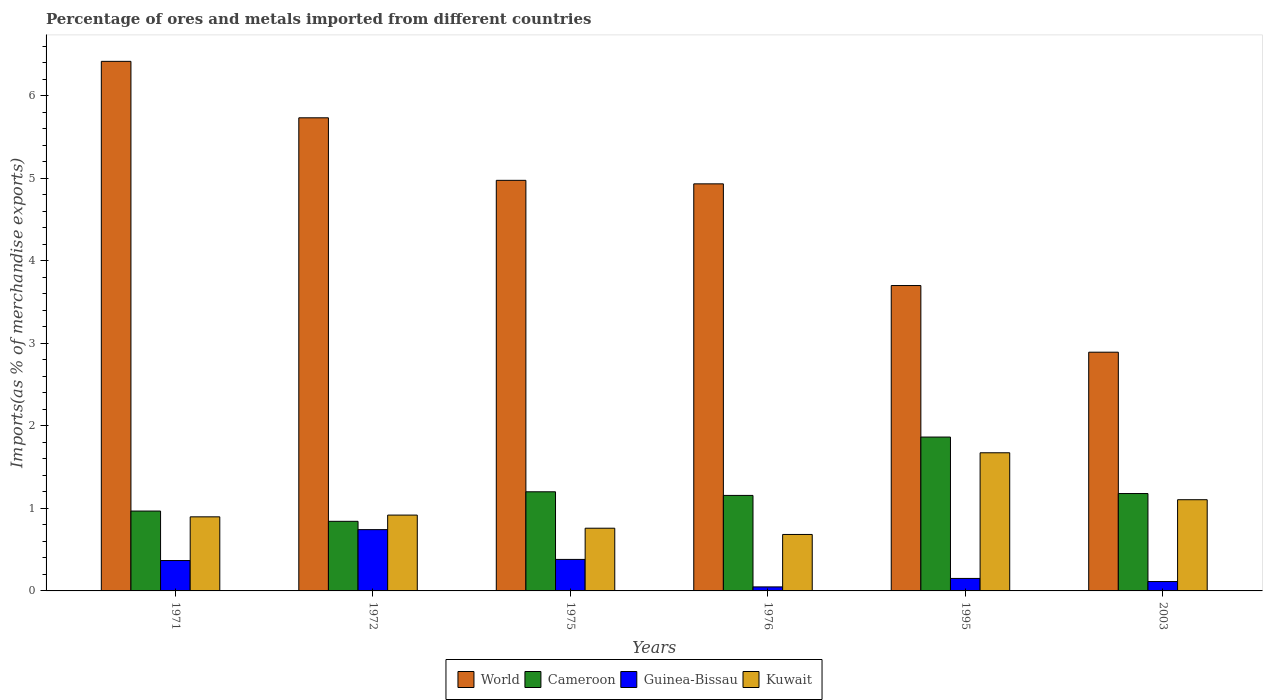Are the number of bars on each tick of the X-axis equal?
Keep it short and to the point. Yes. How many bars are there on the 4th tick from the left?
Offer a terse response. 4. How many bars are there on the 2nd tick from the right?
Your answer should be very brief. 4. In how many cases, is the number of bars for a given year not equal to the number of legend labels?
Provide a short and direct response. 0. What is the percentage of imports to different countries in Guinea-Bissau in 1972?
Ensure brevity in your answer.  0.74. Across all years, what is the maximum percentage of imports to different countries in Guinea-Bissau?
Keep it short and to the point. 0.74. Across all years, what is the minimum percentage of imports to different countries in Cameroon?
Your response must be concise. 0.84. In which year was the percentage of imports to different countries in Kuwait maximum?
Provide a succinct answer. 1995. In which year was the percentage of imports to different countries in Guinea-Bissau minimum?
Ensure brevity in your answer.  1976. What is the total percentage of imports to different countries in Guinea-Bissau in the graph?
Make the answer very short. 1.81. What is the difference between the percentage of imports to different countries in World in 1975 and that in 1995?
Your answer should be compact. 1.27. What is the difference between the percentage of imports to different countries in World in 1976 and the percentage of imports to different countries in Cameroon in 1995?
Offer a very short reply. 3.07. What is the average percentage of imports to different countries in Guinea-Bissau per year?
Keep it short and to the point. 0.3. In the year 1976, what is the difference between the percentage of imports to different countries in Guinea-Bissau and percentage of imports to different countries in World?
Make the answer very short. -4.88. In how many years, is the percentage of imports to different countries in Kuwait greater than 2 %?
Ensure brevity in your answer.  0. What is the ratio of the percentage of imports to different countries in Cameroon in 1971 to that in 2003?
Give a very brief answer. 0.82. Is the percentage of imports to different countries in Kuwait in 1971 less than that in 1976?
Give a very brief answer. No. What is the difference between the highest and the second highest percentage of imports to different countries in World?
Keep it short and to the point. 0.68. What is the difference between the highest and the lowest percentage of imports to different countries in Cameroon?
Offer a terse response. 1.02. In how many years, is the percentage of imports to different countries in Cameroon greater than the average percentage of imports to different countries in Cameroon taken over all years?
Give a very brief answer. 1. Is it the case that in every year, the sum of the percentage of imports to different countries in Kuwait and percentage of imports to different countries in Guinea-Bissau is greater than the sum of percentage of imports to different countries in Cameroon and percentage of imports to different countries in World?
Provide a succinct answer. No. What does the 3rd bar from the left in 1971 represents?
Offer a very short reply. Guinea-Bissau. What does the 3rd bar from the right in 1972 represents?
Give a very brief answer. Cameroon. How many bars are there?
Your answer should be very brief. 24. Are all the bars in the graph horizontal?
Your response must be concise. No. How many years are there in the graph?
Offer a terse response. 6. What is the difference between two consecutive major ticks on the Y-axis?
Your answer should be very brief. 1. Are the values on the major ticks of Y-axis written in scientific E-notation?
Your answer should be very brief. No. Does the graph contain any zero values?
Provide a short and direct response. No. Where does the legend appear in the graph?
Keep it short and to the point. Bottom center. What is the title of the graph?
Give a very brief answer. Percentage of ores and metals imported from different countries. Does "Lesotho" appear as one of the legend labels in the graph?
Provide a short and direct response. No. What is the label or title of the X-axis?
Make the answer very short. Years. What is the label or title of the Y-axis?
Provide a succinct answer. Imports(as % of merchandise exports). What is the Imports(as % of merchandise exports) in World in 1971?
Your answer should be compact. 6.42. What is the Imports(as % of merchandise exports) of Cameroon in 1971?
Offer a terse response. 0.97. What is the Imports(as % of merchandise exports) of Guinea-Bissau in 1971?
Make the answer very short. 0.37. What is the Imports(as % of merchandise exports) of Kuwait in 1971?
Keep it short and to the point. 0.9. What is the Imports(as % of merchandise exports) of World in 1972?
Make the answer very short. 5.73. What is the Imports(as % of merchandise exports) of Cameroon in 1972?
Make the answer very short. 0.84. What is the Imports(as % of merchandise exports) in Guinea-Bissau in 1972?
Offer a terse response. 0.74. What is the Imports(as % of merchandise exports) in Kuwait in 1972?
Your answer should be compact. 0.92. What is the Imports(as % of merchandise exports) of World in 1975?
Your answer should be compact. 4.98. What is the Imports(as % of merchandise exports) of Cameroon in 1975?
Ensure brevity in your answer.  1.2. What is the Imports(as % of merchandise exports) in Guinea-Bissau in 1975?
Keep it short and to the point. 0.38. What is the Imports(as % of merchandise exports) of Kuwait in 1975?
Offer a terse response. 0.76. What is the Imports(as % of merchandise exports) of World in 1976?
Ensure brevity in your answer.  4.93. What is the Imports(as % of merchandise exports) in Cameroon in 1976?
Make the answer very short. 1.16. What is the Imports(as % of merchandise exports) in Guinea-Bissau in 1976?
Offer a very short reply. 0.05. What is the Imports(as % of merchandise exports) of Kuwait in 1976?
Ensure brevity in your answer.  0.68. What is the Imports(as % of merchandise exports) of World in 1995?
Provide a succinct answer. 3.7. What is the Imports(as % of merchandise exports) in Cameroon in 1995?
Make the answer very short. 1.86. What is the Imports(as % of merchandise exports) of Guinea-Bissau in 1995?
Keep it short and to the point. 0.15. What is the Imports(as % of merchandise exports) of Kuwait in 1995?
Keep it short and to the point. 1.67. What is the Imports(as % of merchandise exports) in World in 2003?
Make the answer very short. 2.89. What is the Imports(as % of merchandise exports) of Cameroon in 2003?
Offer a terse response. 1.18. What is the Imports(as % of merchandise exports) in Guinea-Bissau in 2003?
Offer a very short reply. 0.11. What is the Imports(as % of merchandise exports) in Kuwait in 2003?
Offer a very short reply. 1.11. Across all years, what is the maximum Imports(as % of merchandise exports) of World?
Provide a succinct answer. 6.42. Across all years, what is the maximum Imports(as % of merchandise exports) in Cameroon?
Give a very brief answer. 1.86. Across all years, what is the maximum Imports(as % of merchandise exports) in Guinea-Bissau?
Your answer should be very brief. 0.74. Across all years, what is the maximum Imports(as % of merchandise exports) in Kuwait?
Make the answer very short. 1.67. Across all years, what is the minimum Imports(as % of merchandise exports) in World?
Provide a succinct answer. 2.89. Across all years, what is the minimum Imports(as % of merchandise exports) of Cameroon?
Give a very brief answer. 0.84. Across all years, what is the minimum Imports(as % of merchandise exports) in Guinea-Bissau?
Offer a terse response. 0.05. Across all years, what is the minimum Imports(as % of merchandise exports) in Kuwait?
Your answer should be compact. 0.68. What is the total Imports(as % of merchandise exports) in World in the graph?
Ensure brevity in your answer.  28.65. What is the total Imports(as % of merchandise exports) of Cameroon in the graph?
Keep it short and to the point. 7.21. What is the total Imports(as % of merchandise exports) in Guinea-Bissau in the graph?
Provide a succinct answer. 1.81. What is the total Imports(as % of merchandise exports) of Kuwait in the graph?
Offer a terse response. 6.04. What is the difference between the Imports(as % of merchandise exports) in World in 1971 and that in 1972?
Your answer should be compact. 0.68. What is the difference between the Imports(as % of merchandise exports) in Cameroon in 1971 and that in 1972?
Your answer should be compact. 0.12. What is the difference between the Imports(as % of merchandise exports) in Guinea-Bissau in 1971 and that in 1972?
Keep it short and to the point. -0.37. What is the difference between the Imports(as % of merchandise exports) of Kuwait in 1971 and that in 1972?
Provide a short and direct response. -0.02. What is the difference between the Imports(as % of merchandise exports) of World in 1971 and that in 1975?
Ensure brevity in your answer.  1.44. What is the difference between the Imports(as % of merchandise exports) in Cameroon in 1971 and that in 1975?
Offer a very short reply. -0.23. What is the difference between the Imports(as % of merchandise exports) of Guinea-Bissau in 1971 and that in 1975?
Your answer should be compact. -0.01. What is the difference between the Imports(as % of merchandise exports) in Kuwait in 1971 and that in 1975?
Offer a very short reply. 0.14. What is the difference between the Imports(as % of merchandise exports) of World in 1971 and that in 1976?
Make the answer very short. 1.48. What is the difference between the Imports(as % of merchandise exports) in Cameroon in 1971 and that in 1976?
Your answer should be compact. -0.19. What is the difference between the Imports(as % of merchandise exports) in Guinea-Bissau in 1971 and that in 1976?
Give a very brief answer. 0.32. What is the difference between the Imports(as % of merchandise exports) in Kuwait in 1971 and that in 1976?
Make the answer very short. 0.21. What is the difference between the Imports(as % of merchandise exports) in World in 1971 and that in 1995?
Keep it short and to the point. 2.72. What is the difference between the Imports(as % of merchandise exports) in Cameroon in 1971 and that in 1995?
Give a very brief answer. -0.9. What is the difference between the Imports(as % of merchandise exports) in Guinea-Bissau in 1971 and that in 1995?
Your answer should be very brief. 0.22. What is the difference between the Imports(as % of merchandise exports) in Kuwait in 1971 and that in 1995?
Your response must be concise. -0.78. What is the difference between the Imports(as % of merchandise exports) of World in 1971 and that in 2003?
Ensure brevity in your answer.  3.52. What is the difference between the Imports(as % of merchandise exports) of Cameroon in 1971 and that in 2003?
Keep it short and to the point. -0.21. What is the difference between the Imports(as % of merchandise exports) in Guinea-Bissau in 1971 and that in 2003?
Your response must be concise. 0.25. What is the difference between the Imports(as % of merchandise exports) in Kuwait in 1971 and that in 2003?
Your answer should be compact. -0.21. What is the difference between the Imports(as % of merchandise exports) of World in 1972 and that in 1975?
Keep it short and to the point. 0.76. What is the difference between the Imports(as % of merchandise exports) of Cameroon in 1972 and that in 1975?
Give a very brief answer. -0.36. What is the difference between the Imports(as % of merchandise exports) in Guinea-Bissau in 1972 and that in 1975?
Keep it short and to the point. 0.36. What is the difference between the Imports(as % of merchandise exports) in Kuwait in 1972 and that in 1975?
Ensure brevity in your answer.  0.16. What is the difference between the Imports(as % of merchandise exports) in World in 1972 and that in 1976?
Keep it short and to the point. 0.8. What is the difference between the Imports(as % of merchandise exports) in Cameroon in 1972 and that in 1976?
Make the answer very short. -0.31. What is the difference between the Imports(as % of merchandise exports) in Guinea-Bissau in 1972 and that in 1976?
Provide a succinct answer. 0.69. What is the difference between the Imports(as % of merchandise exports) in Kuwait in 1972 and that in 1976?
Offer a terse response. 0.23. What is the difference between the Imports(as % of merchandise exports) of World in 1972 and that in 1995?
Provide a short and direct response. 2.03. What is the difference between the Imports(as % of merchandise exports) of Cameroon in 1972 and that in 1995?
Give a very brief answer. -1.02. What is the difference between the Imports(as % of merchandise exports) of Guinea-Bissau in 1972 and that in 1995?
Your answer should be compact. 0.59. What is the difference between the Imports(as % of merchandise exports) of Kuwait in 1972 and that in 1995?
Your response must be concise. -0.76. What is the difference between the Imports(as % of merchandise exports) in World in 1972 and that in 2003?
Keep it short and to the point. 2.84. What is the difference between the Imports(as % of merchandise exports) in Cameroon in 1972 and that in 2003?
Ensure brevity in your answer.  -0.34. What is the difference between the Imports(as % of merchandise exports) of Guinea-Bissau in 1972 and that in 2003?
Your answer should be compact. 0.63. What is the difference between the Imports(as % of merchandise exports) of Kuwait in 1972 and that in 2003?
Provide a short and direct response. -0.19. What is the difference between the Imports(as % of merchandise exports) in World in 1975 and that in 1976?
Your answer should be compact. 0.04. What is the difference between the Imports(as % of merchandise exports) of Cameroon in 1975 and that in 1976?
Keep it short and to the point. 0.04. What is the difference between the Imports(as % of merchandise exports) in Guinea-Bissau in 1975 and that in 1976?
Ensure brevity in your answer.  0.33. What is the difference between the Imports(as % of merchandise exports) in Kuwait in 1975 and that in 1976?
Offer a terse response. 0.08. What is the difference between the Imports(as % of merchandise exports) of World in 1975 and that in 1995?
Provide a succinct answer. 1.27. What is the difference between the Imports(as % of merchandise exports) in Cameroon in 1975 and that in 1995?
Provide a succinct answer. -0.66. What is the difference between the Imports(as % of merchandise exports) of Guinea-Bissau in 1975 and that in 1995?
Offer a terse response. 0.23. What is the difference between the Imports(as % of merchandise exports) of Kuwait in 1975 and that in 1995?
Provide a succinct answer. -0.91. What is the difference between the Imports(as % of merchandise exports) in World in 1975 and that in 2003?
Provide a succinct answer. 2.08. What is the difference between the Imports(as % of merchandise exports) in Cameroon in 1975 and that in 2003?
Ensure brevity in your answer.  0.02. What is the difference between the Imports(as % of merchandise exports) of Guinea-Bissau in 1975 and that in 2003?
Your answer should be compact. 0.27. What is the difference between the Imports(as % of merchandise exports) in Kuwait in 1975 and that in 2003?
Ensure brevity in your answer.  -0.35. What is the difference between the Imports(as % of merchandise exports) in World in 1976 and that in 1995?
Your response must be concise. 1.23. What is the difference between the Imports(as % of merchandise exports) of Cameroon in 1976 and that in 1995?
Offer a terse response. -0.71. What is the difference between the Imports(as % of merchandise exports) of Guinea-Bissau in 1976 and that in 1995?
Provide a short and direct response. -0.1. What is the difference between the Imports(as % of merchandise exports) in Kuwait in 1976 and that in 1995?
Give a very brief answer. -0.99. What is the difference between the Imports(as % of merchandise exports) in World in 1976 and that in 2003?
Provide a succinct answer. 2.04. What is the difference between the Imports(as % of merchandise exports) in Cameroon in 1976 and that in 2003?
Offer a very short reply. -0.02. What is the difference between the Imports(as % of merchandise exports) in Guinea-Bissau in 1976 and that in 2003?
Give a very brief answer. -0.07. What is the difference between the Imports(as % of merchandise exports) of Kuwait in 1976 and that in 2003?
Keep it short and to the point. -0.42. What is the difference between the Imports(as % of merchandise exports) in World in 1995 and that in 2003?
Provide a succinct answer. 0.81. What is the difference between the Imports(as % of merchandise exports) of Cameroon in 1995 and that in 2003?
Your answer should be compact. 0.68. What is the difference between the Imports(as % of merchandise exports) in Guinea-Bissau in 1995 and that in 2003?
Provide a short and direct response. 0.04. What is the difference between the Imports(as % of merchandise exports) in Kuwait in 1995 and that in 2003?
Your answer should be compact. 0.57. What is the difference between the Imports(as % of merchandise exports) of World in 1971 and the Imports(as % of merchandise exports) of Cameroon in 1972?
Your answer should be compact. 5.57. What is the difference between the Imports(as % of merchandise exports) in World in 1971 and the Imports(as % of merchandise exports) in Guinea-Bissau in 1972?
Make the answer very short. 5.67. What is the difference between the Imports(as % of merchandise exports) in World in 1971 and the Imports(as % of merchandise exports) in Kuwait in 1972?
Provide a short and direct response. 5.5. What is the difference between the Imports(as % of merchandise exports) of Cameroon in 1971 and the Imports(as % of merchandise exports) of Guinea-Bissau in 1972?
Your response must be concise. 0.23. What is the difference between the Imports(as % of merchandise exports) of Cameroon in 1971 and the Imports(as % of merchandise exports) of Kuwait in 1972?
Make the answer very short. 0.05. What is the difference between the Imports(as % of merchandise exports) in Guinea-Bissau in 1971 and the Imports(as % of merchandise exports) in Kuwait in 1972?
Offer a terse response. -0.55. What is the difference between the Imports(as % of merchandise exports) in World in 1971 and the Imports(as % of merchandise exports) in Cameroon in 1975?
Offer a very short reply. 5.22. What is the difference between the Imports(as % of merchandise exports) of World in 1971 and the Imports(as % of merchandise exports) of Guinea-Bissau in 1975?
Provide a short and direct response. 6.04. What is the difference between the Imports(as % of merchandise exports) of World in 1971 and the Imports(as % of merchandise exports) of Kuwait in 1975?
Ensure brevity in your answer.  5.66. What is the difference between the Imports(as % of merchandise exports) of Cameroon in 1971 and the Imports(as % of merchandise exports) of Guinea-Bissau in 1975?
Offer a terse response. 0.59. What is the difference between the Imports(as % of merchandise exports) of Cameroon in 1971 and the Imports(as % of merchandise exports) of Kuwait in 1975?
Offer a terse response. 0.21. What is the difference between the Imports(as % of merchandise exports) in Guinea-Bissau in 1971 and the Imports(as % of merchandise exports) in Kuwait in 1975?
Provide a short and direct response. -0.39. What is the difference between the Imports(as % of merchandise exports) in World in 1971 and the Imports(as % of merchandise exports) in Cameroon in 1976?
Give a very brief answer. 5.26. What is the difference between the Imports(as % of merchandise exports) of World in 1971 and the Imports(as % of merchandise exports) of Guinea-Bissau in 1976?
Offer a terse response. 6.37. What is the difference between the Imports(as % of merchandise exports) of World in 1971 and the Imports(as % of merchandise exports) of Kuwait in 1976?
Give a very brief answer. 5.73. What is the difference between the Imports(as % of merchandise exports) in Cameroon in 1971 and the Imports(as % of merchandise exports) in Guinea-Bissau in 1976?
Offer a terse response. 0.92. What is the difference between the Imports(as % of merchandise exports) in Cameroon in 1971 and the Imports(as % of merchandise exports) in Kuwait in 1976?
Make the answer very short. 0.28. What is the difference between the Imports(as % of merchandise exports) of Guinea-Bissau in 1971 and the Imports(as % of merchandise exports) of Kuwait in 1976?
Your response must be concise. -0.32. What is the difference between the Imports(as % of merchandise exports) of World in 1971 and the Imports(as % of merchandise exports) of Cameroon in 1995?
Provide a short and direct response. 4.55. What is the difference between the Imports(as % of merchandise exports) of World in 1971 and the Imports(as % of merchandise exports) of Guinea-Bissau in 1995?
Your answer should be very brief. 6.27. What is the difference between the Imports(as % of merchandise exports) in World in 1971 and the Imports(as % of merchandise exports) in Kuwait in 1995?
Keep it short and to the point. 4.74. What is the difference between the Imports(as % of merchandise exports) in Cameroon in 1971 and the Imports(as % of merchandise exports) in Guinea-Bissau in 1995?
Give a very brief answer. 0.82. What is the difference between the Imports(as % of merchandise exports) in Cameroon in 1971 and the Imports(as % of merchandise exports) in Kuwait in 1995?
Ensure brevity in your answer.  -0.71. What is the difference between the Imports(as % of merchandise exports) of Guinea-Bissau in 1971 and the Imports(as % of merchandise exports) of Kuwait in 1995?
Offer a very short reply. -1.31. What is the difference between the Imports(as % of merchandise exports) in World in 1971 and the Imports(as % of merchandise exports) in Cameroon in 2003?
Your answer should be very brief. 5.24. What is the difference between the Imports(as % of merchandise exports) of World in 1971 and the Imports(as % of merchandise exports) of Guinea-Bissau in 2003?
Give a very brief answer. 6.3. What is the difference between the Imports(as % of merchandise exports) in World in 1971 and the Imports(as % of merchandise exports) in Kuwait in 2003?
Make the answer very short. 5.31. What is the difference between the Imports(as % of merchandise exports) in Cameroon in 1971 and the Imports(as % of merchandise exports) in Guinea-Bissau in 2003?
Your answer should be very brief. 0.85. What is the difference between the Imports(as % of merchandise exports) in Cameroon in 1971 and the Imports(as % of merchandise exports) in Kuwait in 2003?
Offer a terse response. -0.14. What is the difference between the Imports(as % of merchandise exports) of Guinea-Bissau in 1971 and the Imports(as % of merchandise exports) of Kuwait in 2003?
Ensure brevity in your answer.  -0.74. What is the difference between the Imports(as % of merchandise exports) of World in 1972 and the Imports(as % of merchandise exports) of Cameroon in 1975?
Provide a succinct answer. 4.53. What is the difference between the Imports(as % of merchandise exports) in World in 1972 and the Imports(as % of merchandise exports) in Guinea-Bissau in 1975?
Your answer should be very brief. 5.35. What is the difference between the Imports(as % of merchandise exports) in World in 1972 and the Imports(as % of merchandise exports) in Kuwait in 1975?
Your response must be concise. 4.97. What is the difference between the Imports(as % of merchandise exports) in Cameroon in 1972 and the Imports(as % of merchandise exports) in Guinea-Bissau in 1975?
Provide a short and direct response. 0.46. What is the difference between the Imports(as % of merchandise exports) of Cameroon in 1972 and the Imports(as % of merchandise exports) of Kuwait in 1975?
Provide a succinct answer. 0.08. What is the difference between the Imports(as % of merchandise exports) of Guinea-Bissau in 1972 and the Imports(as % of merchandise exports) of Kuwait in 1975?
Your answer should be compact. -0.02. What is the difference between the Imports(as % of merchandise exports) in World in 1972 and the Imports(as % of merchandise exports) in Cameroon in 1976?
Ensure brevity in your answer.  4.58. What is the difference between the Imports(as % of merchandise exports) in World in 1972 and the Imports(as % of merchandise exports) in Guinea-Bissau in 1976?
Your response must be concise. 5.68. What is the difference between the Imports(as % of merchandise exports) in World in 1972 and the Imports(as % of merchandise exports) in Kuwait in 1976?
Provide a succinct answer. 5.05. What is the difference between the Imports(as % of merchandise exports) in Cameroon in 1972 and the Imports(as % of merchandise exports) in Guinea-Bissau in 1976?
Offer a very short reply. 0.79. What is the difference between the Imports(as % of merchandise exports) of Cameroon in 1972 and the Imports(as % of merchandise exports) of Kuwait in 1976?
Give a very brief answer. 0.16. What is the difference between the Imports(as % of merchandise exports) of Guinea-Bissau in 1972 and the Imports(as % of merchandise exports) of Kuwait in 1976?
Your response must be concise. 0.06. What is the difference between the Imports(as % of merchandise exports) of World in 1972 and the Imports(as % of merchandise exports) of Cameroon in 1995?
Your response must be concise. 3.87. What is the difference between the Imports(as % of merchandise exports) of World in 1972 and the Imports(as % of merchandise exports) of Guinea-Bissau in 1995?
Give a very brief answer. 5.58. What is the difference between the Imports(as % of merchandise exports) of World in 1972 and the Imports(as % of merchandise exports) of Kuwait in 1995?
Your response must be concise. 4.06. What is the difference between the Imports(as % of merchandise exports) of Cameroon in 1972 and the Imports(as % of merchandise exports) of Guinea-Bissau in 1995?
Ensure brevity in your answer.  0.69. What is the difference between the Imports(as % of merchandise exports) of Cameroon in 1972 and the Imports(as % of merchandise exports) of Kuwait in 1995?
Make the answer very short. -0.83. What is the difference between the Imports(as % of merchandise exports) in Guinea-Bissau in 1972 and the Imports(as % of merchandise exports) in Kuwait in 1995?
Offer a terse response. -0.93. What is the difference between the Imports(as % of merchandise exports) of World in 1972 and the Imports(as % of merchandise exports) of Cameroon in 2003?
Your answer should be compact. 4.55. What is the difference between the Imports(as % of merchandise exports) of World in 1972 and the Imports(as % of merchandise exports) of Guinea-Bissau in 2003?
Give a very brief answer. 5.62. What is the difference between the Imports(as % of merchandise exports) of World in 1972 and the Imports(as % of merchandise exports) of Kuwait in 2003?
Provide a short and direct response. 4.63. What is the difference between the Imports(as % of merchandise exports) of Cameroon in 1972 and the Imports(as % of merchandise exports) of Guinea-Bissau in 2003?
Give a very brief answer. 0.73. What is the difference between the Imports(as % of merchandise exports) in Cameroon in 1972 and the Imports(as % of merchandise exports) in Kuwait in 2003?
Make the answer very short. -0.26. What is the difference between the Imports(as % of merchandise exports) in Guinea-Bissau in 1972 and the Imports(as % of merchandise exports) in Kuwait in 2003?
Keep it short and to the point. -0.36. What is the difference between the Imports(as % of merchandise exports) of World in 1975 and the Imports(as % of merchandise exports) of Cameroon in 1976?
Your response must be concise. 3.82. What is the difference between the Imports(as % of merchandise exports) in World in 1975 and the Imports(as % of merchandise exports) in Guinea-Bissau in 1976?
Provide a short and direct response. 4.93. What is the difference between the Imports(as % of merchandise exports) in World in 1975 and the Imports(as % of merchandise exports) in Kuwait in 1976?
Make the answer very short. 4.29. What is the difference between the Imports(as % of merchandise exports) in Cameroon in 1975 and the Imports(as % of merchandise exports) in Guinea-Bissau in 1976?
Your response must be concise. 1.15. What is the difference between the Imports(as % of merchandise exports) in Cameroon in 1975 and the Imports(as % of merchandise exports) in Kuwait in 1976?
Make the answer very short. 0.52. What is the difference between the Imports(as % of merchandise exports) in Guinea-Bissau in 1975 and the Imports(as % of merchandise exports) in Kuwait in 1976?
Offer a very short reply. -0.3. What is the difference between the Imports(as % of merchandise exports) of World in 1975 and the Imports(as % of merchandise exports) of Cameroon in 1995?
Your answer should be very brief. 3.11. What is the difference between the Imports(as % of merchandise exports) in World in 1975 and the Imports(as % of merchandise exports) in Guinea-Bissau in 1995?
Offer a very short reply. 4.82. What is the difference between the Imports(as % of merchandise exports) of World in 1975 and the Imports(as % of merchandise exports) of Kuwait in 1995?
Provide a succinct answer. 3.3. What is the difference between the Imports(as % of merchandise exports) in Cameroon in 1975 and the Imports(as % of merchandise exports) in Guinea-Bissau in 1995?
Your response must be concise. 1.05. What is the difference between the Imports(as % of merchandise exports) in Cameroon in 1975 and the Imports(as % of merchandise exports) in Kuwait in 1995?
Your answer should be compact. -0.47. What is the difference between the Imports(as % of merchandise exports) in Guinea-Bissau in 1975 and the Imports(as % of merchandise exports) in Kuwait in 1995?
Ensure brevity in your answer.  -1.29. What is the difference between the Imports(as % of merchandise exports) of World in 1975 and the Imports(as % of merchandise exports) of Cameroon in 2003?
Make the answer very short. 3.8. What is the difference between the Imports(as % of merchandise exports) in World in 1975 and the Imports(as % of merchandise exports) in Guinea-Bissau in 2003?
Provide a succinct answer. 4.86. What is the difference between the Imports(as % of merchandise exports) of World in 1975 and the Imports(as % of merchandise exports) of Kuwait in 2003?
Keep it short and to the point. 3.87. What is the difference between the Imports(as % of merchandise exports) of Cameroon in 1975 and the Imports(as % of merchandise exports) of Guinea-Bissau in 2003?
Ensure brevity in your answer.  1.09. What is the difference between the Imports(as % of merchandise exports) of Cameroon in 1975 and the Imports(as % of merchandise exports) of Kuwait in 2003?
Your answer should be very brief. 0.1. What is the difference between the Imports(as % of merchandise exports) in Guinea-Bissau in 1975 and the Imports(as % of merchandise exports) in Kuwait in 2003?
Offer a very short reply. -0.72. What is the difference between the Imports(as % of merchandise exports) of World in 1976 and the Imports(as % of merchandise exports) of Cameroon in 1995?
Make the answer very short. 3.07. What is the difference between the Imports(as % of merchandise exports) in World in 1976 and the Imports(as % of merchandise exports) in Guinea-Bissau in 1995?
Provide a short and direct response. 4.78. What is the difference between the Imports(as % of merchandise exports) of World in 1976 and the Imports(as % of merchandise exports) of Kuwait in 1995?
Offer a terse response. 3.26. What is the difference between the Imports(as % of merchandise exports) of Cameroon in 1976 and the Imports(as % of merchandise exports) of Guinea-Bissau in 1995?
Give a very brief answer. 1.01. What is the difference between the Imports(as % of merchandise exports) of Cameroon in 1976 and the Imports(as % of merchandise exports) of Kuwait in 1995?
Offer a very short reply. -0.52. What is the difference between the Imports(as % of merchandise exports) of Guinea-Bissau in 1976 and the Imports(as % of merchandise exports) of Kuwait in 1995?
Keep it short and to the point. -1.63. What is the difference between the Imports(as % of merchandise exports) of World in 1976 and the Imports(as % of merchandise exports) of Cameroon in 2003?
Provide a short and direct response. 3.75. What is the difference between the Imports(as % of merchandise exports) of World in 1976 and the Imports(as % of merchandise exports) of Guinea-Bissau in 2003?
Your answer should be compact. 4.82. What is the difference between the Imports(as % of merchandise exports) of World in 1976 and the Imports(as % of merchandise exports) of Kuwait in 2003?
Your answer should be very brief. 3.83. What is the difference between the Imports(as % of merchandise exports) in Cameroon in 1976 and the Imports(as % of merchandise exports) in Guinea-Bissau in 2003?
Make the answer very short. 1.04. What is the difference between the Imports(as % of merchandise exports) in Cameroon in 1976 and the Imports(as % of merchandise exports) in Kuwait in 2003?
Provide a short and direct response. 0.05. What is the difference between the Imports(as % of merchandise exports) of Guinea-Bissau in 1976 and the Imports(as % of merchandise exports) of Kuwait in 2003?
Your answer should be compact. -1.06. What is the difference between the Imports(as % of merchandise exports) in World in 1995 and the Imports(as % of merchandise exports) in Cameroon in 2003?
Ensure brevity in your answer.  2.52. What is the difference between the Imports(as % of merchandise exports) of World in 1995 and the Imports(as % of merchandise exports) of Guinea-Bissau in 2003?
Your answer should be compact. 3.59. What is the difference between the Imports(as % of merchandise exports) of World in 1995 and the Imports(as % of merchandise exports) of Kuwait in 2003?
Give a very brief answer. 2.6. What is the difference between the Imports(as % of merchandise exports) of Cameroon in 1995 and the Imports(as % of merchandise exports) of Guinea-Bissau in 2003?
Keep it short and to the point. 1.75. What is the difference between the Imports(as % of merchandise exports) in Cameroon in 1995 and the Imports(as % of merchandise exports) in Kuwait in 2003?
Offer a very short reply. 0.76. What is the difference between the Imports(as % of merchandise exports) in Guinea-Bissau in 1995 and the Imports(as % of merchandise exports) in Kuwait in 2003?
Keep it short and to the point. -0.95. What is the average Imports(as % of merchandise exports) in World per year?
Provide a succinct answer. 4.78. What is the average Imports(as % of merchandise exports) of Cameroon per year?
Ensure brevity in your answer.  1.2. What is the average Imports(as % of merchandise exports) of Guinea-Bissau per year?
Provide a succinct answer. 0.3. What is the average Imports(as % of merchandise exports) in Kuwait per year?
Make the answer very short. 1.01. In the year 1971, what is the difference between the Imports(as % of merchandise exports) in World and Imports(as % of merchandise exports) in Cameroon?
Keep it short and to the point. 5.45. In the year 1971, what is the difference between the Imports(as % of merchandise exports) of World and Imports(as % of merchandise exports) of Guinea-Bissau?
Ensure brevity in your answer.  6.05. In the year 1971, what is the difference between the Imports(as % of merchandise exports) in World and Imports(as % of merchandise exports) in Kuwait?
Ensure brevity in your answer.  5.52. In the year 1971, what is the difference between the Imports(as % of merchandise exports) of Cameroon and Imports(as % of merchandise exports) of Guinea-Bissau?
Offer a very short reply. 0.6. In the year 1971, what is the difference between the Imports(as % of merchandise exports) of Cameroon and Imports(as % of merchandise exports) of Kuwait?
Keep it short and to the point. 0.07. In the year 1971, what is the difference between the Imports(as % of merchandise exports) in Guinea-Bissau and Imports(as % of merchandise exports) in Kuwait?
Your response must be concise. -0.53. In the year 1972, what is the difference between the Imports(as % of merchandise exports) in World and Imports(as % of merchandise exports) in Cameroon?
Ensure brevity in your answer.  4.89. In the year 1972, what is the difference between the Imports(as % of merchandise exports) of World and Imports(as % of merchandise exports) of Guinea-Bissau?
Give a very brief answer. 4.99. In the year 1972, what is the difference between the Imports(as % of merchandise exports) of World and Imports(as % of merchandise exports) of Kuwait?
Make the answer very short. 4.81. In the year 1972, what is the difference between the Imports(as % of merchandise exports) in Cameroon and Imports(as % of merchandise exports) in Guinea-Bissau?
Ensure brevity in your answer.  0.1. In the year 1972, what is the difference between the Imports(as % of merchandise exports) in Cameroon and Imports(as % of merchandise exports) in Kuwait?
Your response must be concise. -0.08. In the year 1972, what is the difference between the Imports(as % of merchandise exports) in Guinea-Bissau and Imports(as % of merchandise exports) in Kuwait?
Your response must be concise. -0.18. In the year 1975, what is the difference between the Imports(as % of merchandise exports) of World and Imports(as % of merchandise exports) of Cameroon?
Ensure brevity in your answer.  3.77. In the year 1975, what is the difference between the Imports(as % of merchandise exports) in World and Imports(as % of merchandise exports) in Guinea-Bissau?
Provide a short and direct response. 4.59. In the year 1975, what is the difference between the Imports(as % of merchandise exports) of World and Imports(as % of merchandise exports) of Kuwait?
Offer a terse response. 4.22. In the year 1975, what is the difference between the Imports(as % of merchandise exports) of Cameroon and Imports(as % of merchandise exports) of Guinea-Bissau?
Offer a terse response. 0.82. In the year 1975, what is the difference between the Imports(as % of merchandise exports) of Cameroon and Imports(as % of merchandise exports) of Kuwait?
Give a very brief answer. 0.44. In the year 1975, what is the difference between the Imports(as % of merchandise exports) in Guinea-Bissau and Imports(as % of merchandise exports) in Kuwait?
Offer a terse response. -0.38. In the year 1976, what is the difference between the Imports(as % of merchandise exports) in World and Imports(as % of merchandise exports) in Cameroon?
Your response must be concise. 3.78. In the year 1976, what is the difference between the Imports(as % of merchandise exports) in World and Imports(as % of merchandise exports) in Guinea-Bissau?
Your answer should be very brief. 4.88. In the year 1976, what is the difference between the Imports(as % of merchandise exports) in World and Imports(as % of merchandise exports) in Kuwait?
Your response must be concise. 4.25. In the year 1976, what is the difference between the Imports(as % of merchandise exports) of Cameroon and Imports(as % of merchandise exports) of Guinea-Bissau?
Keep it short and to the point. 1.11. In the year 1976, what is the difference between the Imports(as % of merchandise exports) of Cameroon and Imports(as % of merchandise exports) of Kuwait?
Your response must be concise. 0.47. In the year 1976, what is the difference between the Imports(as % of merchandise exports) of Guinea-Bissau and Imports(as % of merchandise exports) of Kuwait?
Provide a short and direct response. -0.64. In the year 1995, what is the difference between the Imports(as % of merchandise exports) of World and Imports(as % of merchandise exports) of Cameroon?
Make the answer very short. 1.84. In the year 1995, what is the difference between the Imports(as % of merchandise exports) in World and Imports(as % of merchandise exports) in Guinea-Bissau?
Provide a short and direct response. 3.55. In the year 1995, what is the difference between the Imports(as % of merchandise exports) of World and Imports(as % of merchandise exports) of Kuwait?
Keep it short and to the point. 2.03. In the year 1995, what is the difference between the Imports(as % of merchandise exports) in Cameroon and Imports(as % of merchandise exports) in Guinea-Bissau?
Offer a terse response. 1.71. In the year 1995, what is the difference between the Imports(as % of merchandise exports) of Cameroon and Imports(as % of merchandise exports) of Kuwait?
Make the answer very short. 0.19. In the year 1995, what is the difference between the Imports(as % of merchandise exports) of Guinea-Bissau and Imports(as % of merchandise exports) of Kuwait?
Your response must be concise. -1.52. In the year 2003, what is the difference between the Imports(as % of merchandise exports) of World and Imports(as % of merchandise exports) of Cameroon?
Give a very brief answer. 1.71. In the year 2003, what is the difference between the Imports(as % of merchandise exports) in World and Imports(as % of merchandise exports) in Guinea-Bissau?
Your response must be concise. 2.78. In the year 2003, what is the difference between the Imports(as % of merchandise exports) of World and Imports(as % of merchandise exports) of Kuwait?
Ensure brevity in your answer.  1.79. In the year 2003, what is the difference between the Imports(as % of merchandise exports) of Cameroon and Imports(as % of merchandise exports) of Guinea-Bissau?
Provide a succinct answer. 1.07. In the year 2003, what is the difference between the Imports(as % of merchandise exports) of Cameroon and Imports(as % of merchandise exports) of Kuwait?
Provide a short and direct response. 0.07. In the year 2003, what is the difference between the Imports(as % of merchandise exports) in Guinea-Bissau and Imports(as % of merchandise exports) in Kuwait?
Keep it short and to the point. -0.99. What is the ratio of the Imports(as % of merchandise exports) in World in 1971 to that in 1972?
Provide a succinct answer. 1.12. What is the ratio of the Imports(as % of merchandise exports) of Cameroon in 1971 to that in 1972?
Offer a very short reply. 1.15. What is the ratio of the Imports(as % of merchandise exports) in Guinea-Bissau in 1971 to that in 1972?
Make the answer very short. 0.5. What is the ratio of the Imports(as % of merchandise exports) in Kuwait in 1971 to that in 1972?
Make the answer very short. 0.98. What is the ratio of the Imports(as % of merchandise exports) in World in 1971 to that in 1975?
Your response must be concise. 1.29. What is the ratio of the Imports(as % of merchandise exports) in Cameroon in 1971 to that in 1975?
Your answer should be compact. 0.81. What is the ratio of the Imports(as % of merchandise exports) in Guinea-Bissau in 1971 to that in 1975?
Your answer should be very brief. 0.96. What is the ratio of the Imports(as % of merchandise exports) of Kuwait in 1971 to that in 1975?
Your response must be concise. 1.18. What is the ratio of the Imports(as % of merchandise exports) in World in 1971 to that in 1976?
Offer a terse response. 1.3. What is the ratio of the Imports(as % of merchandise exports) of Cameroon in 1971 to that in 1976?
Offer a very short reply. 0.84. What is the ratio of the Imports(as % of merchandise exports) of Guinea-Bissau in 1971 to that in 1976?
Keep it short and to the point. 7.56. What is the ratio of the Imports(as % of merchandise exports) of Kuwait in 1971 to that in 1976?
Give a very brief answer. 1.31. What is the ratio of the Imports(as % of merchandise exports) in World in 1971 to that in 1995?
Your answer should be very brief. 1.73. What is the ratio of the Imports(as % of merchandise exports) of Cameroon in 1971 to that in 1995?
Make the answer very short. 0.52. What is the ratio of the Imports(as % of merchandise exports) of Guinea-Bissau in 1971 to that in 1995?
Your answer should be very brief. 2.43. What is the ratio of the Imports(as % of merchandise exports) in Kuwait in 1971 to that in 1995?
Your answer should be very brief. 0.54. What is the ratio of the Imports(as % of merchandise exports) in World in 1971 to that in 2003?
Offer a very short reply. 2.22. What is the ratio of the Imports(as % of merchandise exports) of Cameroon in 1971 to that in 2003?
Your response must be concise. 0.82. What is the ratio of the Imports(as % of merchandise exports) in Guinea-Bissau in 1971 to that in 2003?
Offer a very short reply. 3.24. What is the ratio of the Imports(as % of merchandise exports) of Kuwait in 1971 to that in 2003?
Offer a very short reply. 0.81. What is the ratio of the Imports(as % of merchandise exports) of World in 1972 to that in 1975?
Offer a very short reply. 1.15. What is the ratio of the Imports(as % of merchandise exports) of Cameroon in 1972 to that in 1975?
Ensure brevity in your answer.  0.7. What is the ratio of the Imports(as % of merchandise exports) of Guinea-Bissau in 1972 to that in 1975?
Keep it short and to the point. 1.94. What is the ratio of the Imports(as % of merchandise exports) in Kuwait in 1972 to that in 1975?
Your response must be concise. 1.21. What is the ratio of the Imports(as % of merchandise exports) of World in 1972 to that in 1976?
Your response must be concise. 1.16. What is the ratio of the Imports(as % of merchandise exports) of Cameroon in 1972 to that in 1976?
Provide a succinct answer. 0.73. What is the ratio of the Imports(as % of merchandise exports) of Guinea-Bissau in 1972 to that in 1976?
Your answer should be very brief. 15.24. What is the ratio of the Imports(as % of merchandise exports) of Kuwait in 1972 to that in 1976?
Offer a very short reply. 1.34. What is the ratio of the Imports(as % of merchandise exports) of World in 1972 to that in 1995?
Offer a very short reply. 1.55. What is the ratio of the Imports(as % of merchandise exports) of Cameroon in 1972 to that in 1995?
Ensure brevity in your answer.  0.45. What is the ratio of the Imports(as % of merchandise exports) in Guinea-Bissau in 1972 to that in 1995?
Your answer should be very brief. 4.9. What is the ratio of the Imports(as % of merchandise exports) of Kuwait in 1972 to that in 1995?
Offer a very short reply. 0.55. What is the ratio of the Imports(as % of merchandise exports) of World in 1972 to that in 2003?
Offer a very short reply. 1.98. What is the ratio of the Imports(as % of merchandise exports) in Cameroon in 1972 to that in 2003?
Keep it short and to the point. 0.71. What is the ratio of the Imports(as % of merchandise exports) in Guinea-Bissau in 1972 to that in 2003?
Provide a short and direct response. 6.53. What is the ratio of the Imports(as % of merchandise exports) in Kuwait in 1972 to that in 2003?
Your answer should be compact. 0.83. What is the ratio of the Imports(as % of merchandise exports) in World in 1975 to that in 1976?
Your answer should be compact. 1.01. What is the ratio of the Imports(as % of merchandise exports) of Cameroon in 1975 to that in 1976?
Keep it short and to the point. 1.04. What is the ratio of the Imports(as % of merchandise exports) of Guinea-Bissau in 1975 to that in 1976?
Your response must be concise. 7.84. What is the ratio of the Imports(as % of merchandise exports) in Kuwait in 1975 to that in 1976?
Provide a succinct answer. 1.11. What is the ratio of the Imports(as % of merchandise exports) of World in 1975 to that in 1995?
Your response must be concise. 1.34. What is the ratio of the Imports(as % of merchandise exports) in Cameroon in 1975 to that in 1995?
Provide a short and direct response. 0.64. What is the ratio of the Imports(as % of merchandise exports) of Guinea-Bissau in 1975 to that in 1995?
Give a very brief answer. 2.52. What is the ratio of the Imports(as % of merchandise exports) in Kuwait in 1975 to that in 1995?
Your response must be concise. 0.45. What is the ratio of the Imports(as % of merchandise exports) of World in 1975 to that in 2003?
Offer a terse response. 1.72. What is the ratio of the Imports(as % of merchandise exports) of Cameroon in 1975 to that in 2003?
Your answer should be very brief. 1.02. What is the ratio of the Imports(as % of merchandise exports) in Guinea-Bissau in 1975 to that in 2003?
Provide a short and direct response. 3.36. What is the ratio of the Imports(as % of merchandise exports) in Kuwait in 1975 to that in 2003?
Your answer should be compact. 0.69. What is the ratio of the Imports(as % of merchandise exports) of World in 1976 to that in 1995?
Your answer should be very brief. 1.33. What is the ratio of the Imports(as % of merchandise exports) in Cameroon in 1976 to that in 1995?
Offer a very short reply. 0.62. What is the ratio of the Imports(as % of merchandise exports) of Guinea-Bissau in 1976 to that in 1995?
Your response must be concise. 0.32. What is the ratio of the Imports(as % of merchandise exports) in Kuwait in 1976 to that in 1995?
Provide a short and direct response. 0.41. What is the ratio of the Imports(as % of merchandise exports) in World in 1976 to that in 2003?
Offer a terse response. 1.71. What is the ratio of the Imports(as % of merchandise exports) in Cameroon in 1976 to that in 2003?
Your answer should be very brief. 0.98. What is the ratio of the Imports(as % of merchandise exports) of Guinea-Bissau in 1976 to that in 2003?
Provide a succinct answer. 0.43. What is the ratio of the Imports(as % of merchandise exports) of Kuwait in 1976 to that in 2003?
Your answer should be compact. 0.62. What is the ratio of the Imports(as % of merchandise exports) of World in 1995 to that in 2003?
Make the answer very short. 1.28. What is the ratio of the Imports(as % of merchandise exports) in Cameroon in 1995 to that in 2003?
Provide a short and direct response. 1.58. What is the ratio of the Imports(as % of merchandise exports) in Guinea-Bissau in 1995 to that in 2003?
Provide a succinct answer. 1.33. What is the ratio of the Imports(as % of merchandise exports) in Kuwait in 1995 to that in 2003?
Your answer should be very brief. 1.51. What is the difference between the highest and the second highest Imports(as % of merchandise exports) in World?
Keep it short and to the point. 0.68. What is the difference between the highest and the second highest Imports(as % of merchandise exports) of Cameroon?
Your response must be concise. 0.66. What is the difference between the highest and the second highest Imports(as % of merchandise exports) of Guinea-Bissau?
Ensure brevity in your answer.  0.36. What is the difference between the highest and the second highest Imports(as % of merchandise exports) in Kuwait?
Give a very brief answer. 0.57. What is the difference between the highest and the lowest Imports(as % of merchandise exports) in World?
Provide a succinct answer. 3.52. What is the difference between the highest and the lowest Imports(as % of merchandise exports) in Cameroon?
Your answer should be very brief. 1.02. What is the difference between the highest and the lowest Imports(as % of merchandise exports) in Guinea-Bissau?
Your answer should be very brief. 0.69. What is the difference between the highest and the lowest Imports(as % of merchandise exports) in Kuwait?
Provide a short and direct response. 0.99. 